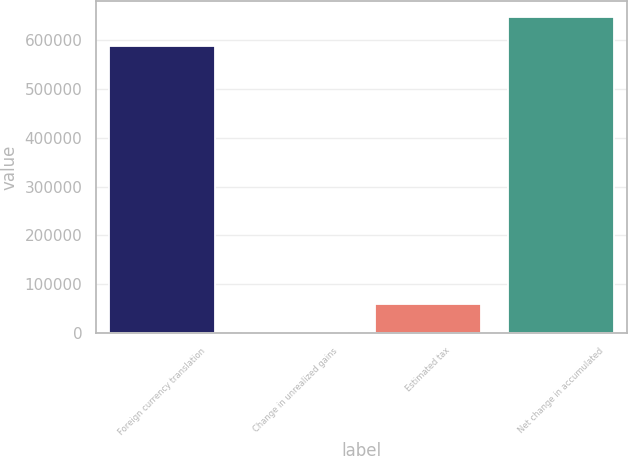<chart> <loc_0><loc_0><loc_500><loc_500><bar_chart><fcel>Foreign currency translation<fcel>Change in unrealized gains<fcel>Estimated tax<fcel>Net change in accumulated<nl><fcel>588150<fcel>194<fcel>59481.3<fcel>647437<nl></chart> 